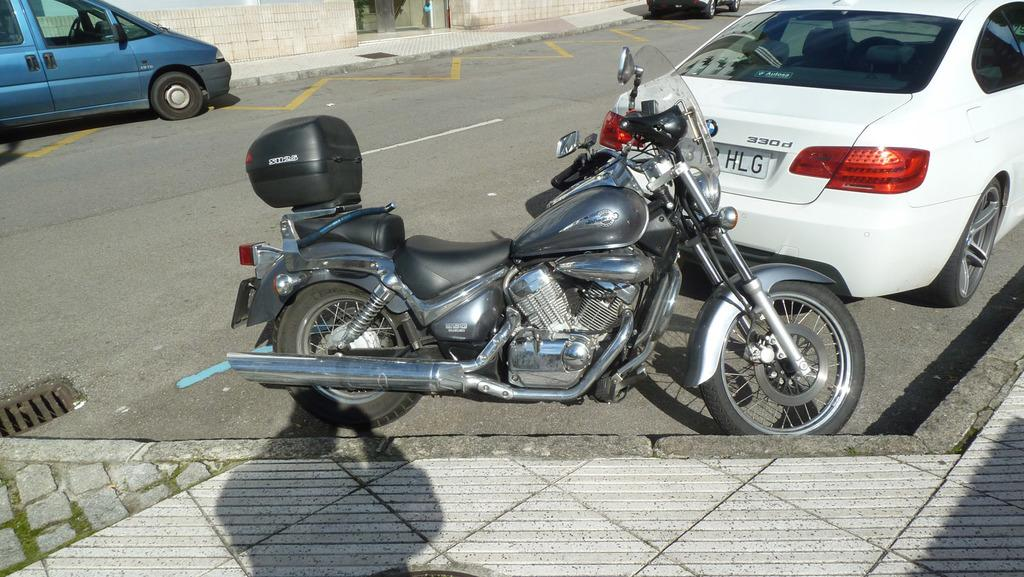What type of transportation is featured in the image? There is a bike and two cars in the image. Can you describe the vehicle on the road? There is a vehicle on the road in the image, but its specific type is not mentioned. What is the surface beneath the vehicles in the image? The bottom of the image contains a pavement. What is located at the top of the image? The top of the image contains a wall. What is the surface between the pavement and the wall? There is a pavement before the wall at the top of the image. What type of celery is growing in the image? There is no celery present in the image. Is there an event taking place in the image? The image does not depict any event; it shows a bike, cars, a vehicle, pavement, and a wall. 